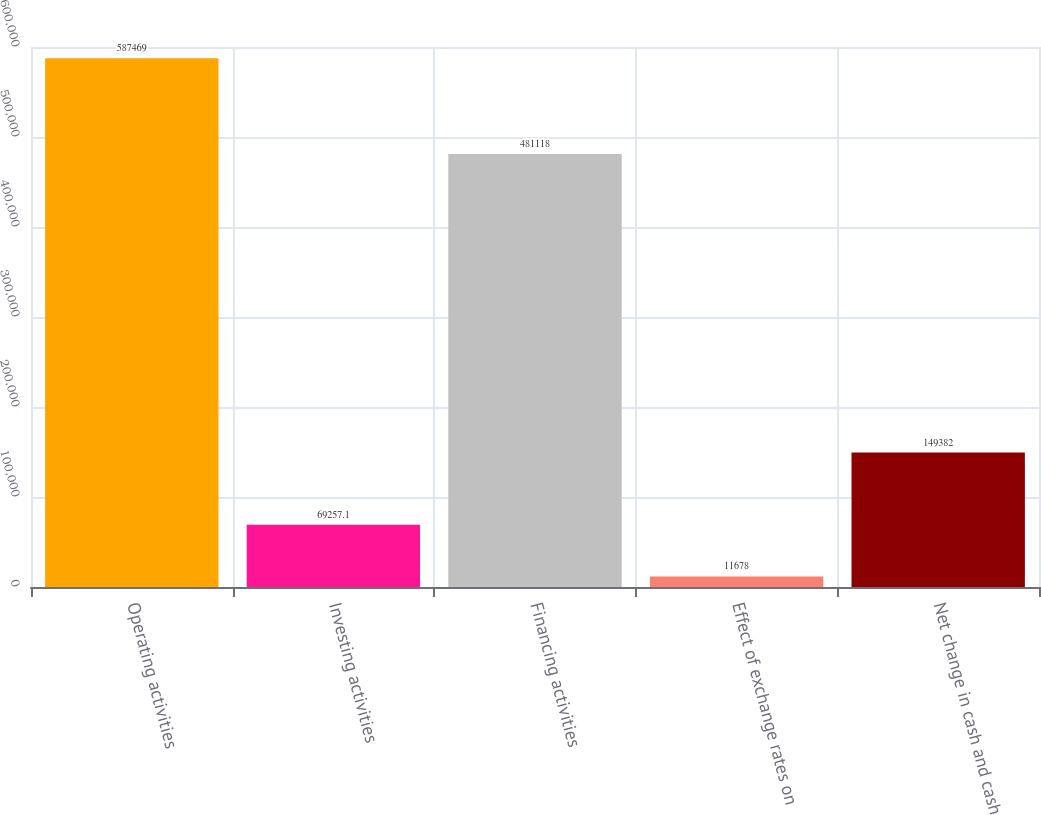Convert chart to OTSL. <chart><loc_0><loc_0><loc_500><loc_500><bar_chart><fcel>Operating activities<fcel>Investing activities<fcel>Financing activities<fcel>Effect of exchange rates on<fcel>Net change in cash and cash<nl><fcel>587469<fcel>69257.1<fcel>481118<fcel>11678<fcel>149382<nl></chart> 